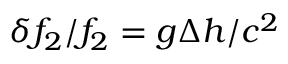<formula> <loc_0><loc_0><loc_500><loc_500>\delta f _ { 2 } / f _ { 2 } = g \Delta h / c ^ { 2 }</formula> 